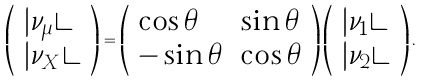Convert formula to latex. <formula><loc_0><loc_0><loc_500><loc_500>\left ( \begin{array} { l } | \nu _ { \mu } \rangle \\ | \nu _ { X } \rangle \end{array} \right ) = \left ( \begin{array} { l l } \cos \theta & \sin \theta \\ - \sin \theta & \cos \theta \end{array} \right ) \left ( \begin{array} { l } | \nu _ { 1 } \rangle \\ | \nu _ { 2 } \rangle \end{array} \right ) .</formula> 